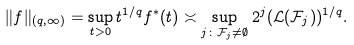<formula> <loc_0><loc_0><loc_500><loc_500>\| f \| _ { ( q , \infty ) } = \sup _ { t > 0 } t ^ { 1 / q } f ^ { * } ( t ) \asymp \sup _ { j \colon \mathcal { F } _ { j } \not = \emptyset } 2 ^ { j } ( \mathcal { L } ( \mathcal { F } _ { j } ) ) ^ { 1 / q } .</formula> 